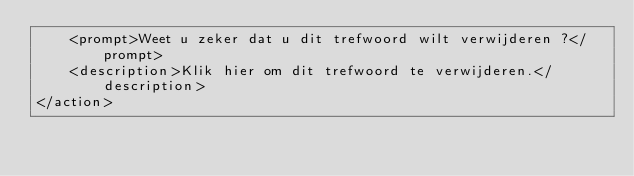<code> <loc_0><loc_0><loc_500><loc_500><_XML_>	<prompt>Weet u zeker dat u dit trefwoord wilt verwijderen ?</prompt>
	<description>Klik hier om dit trefwoord te verwijderen.</description>
</action>
</code> 